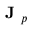Convert formula to latex. <formula><loc_0><loc_0><loc_500><loc_500>J _ { p }</formula> 